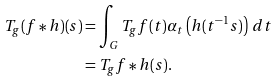<formula> <loc_0><loc_0><loc_500><loc_500>T _ { g } ( f * h ) ( s ) & = \int _ { G } T _ { g } f ( t ) \alpha _ { t } \left ( h ( t ^ { - 1 } s ) \right ) \, d t \\ & = T _ { g } f * h ( s ) .</formula> 